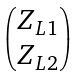<formula> <loc_0><loc_0><loc_500><loc_500>\begin{pmatrix} Z _ { L 1 } \\ Z _ { L 2 } \end{pmatrix}</formula> 